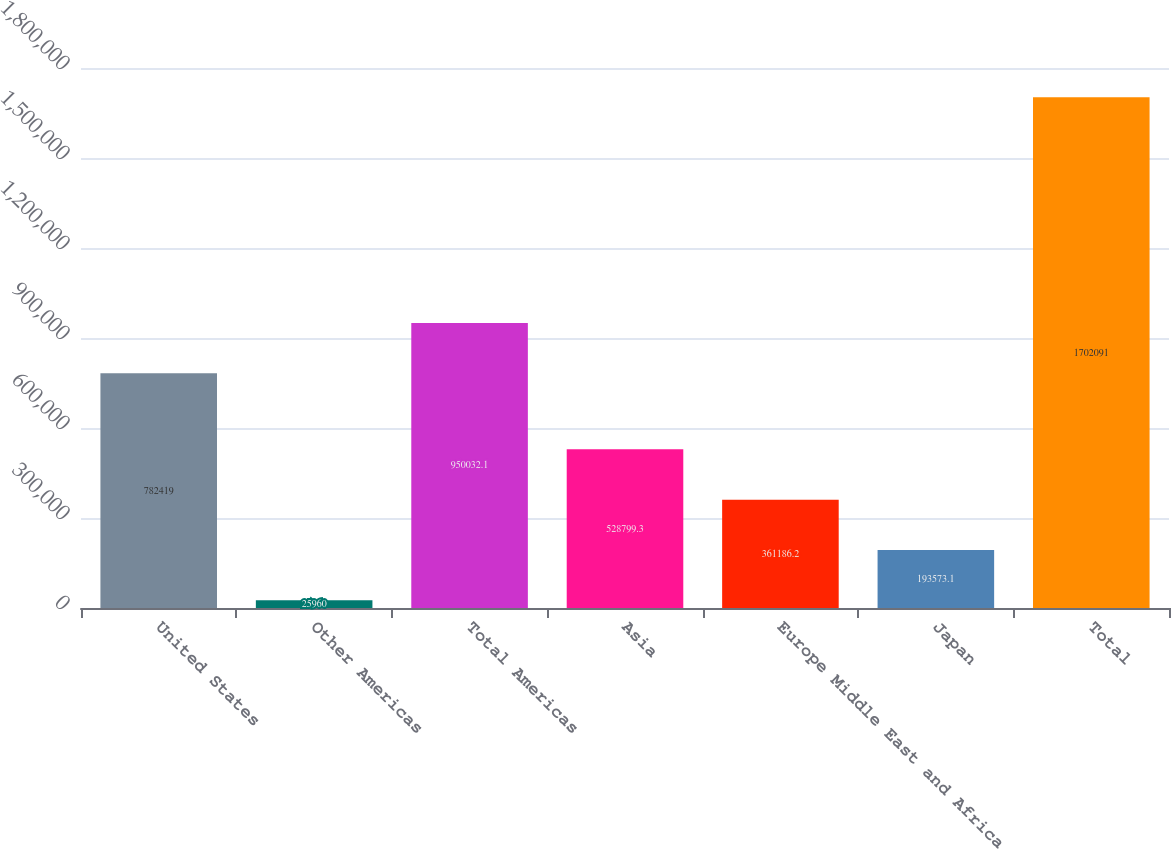Convert chart. <chart><loc_0><loc_0><loc_500><loc_500><bar_chart><fcel>United States<fcel>Other Americas<fcel>Total Americas<fcel>Asia<fcel>Europe Middle East and Africa<fcel>Japan<fcel>Total<nl><fcel>782419<fcel>25960<fcel>950032<fcel>528799<fcel>361186<fcel>193573<fcel>1.70209e+06<nl></chart> 